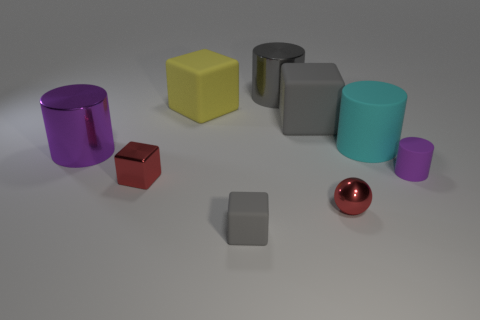Subtract all yellow cubes. How many purple cylinders are left? 2 Add 1 tiny yellow matte things. How many objects exist? 10 Subtract all yellow blocks. How many blocks are left? 3 Subtract all big cyan rubber cylinders. How many cylinders are left? 3 Subtract 1 blocks. How many blocks are left? 3 Subtract all brown cubes. Subtract all red spheres. How many cubes are left? 4 Subtract all blocks. How many objects are left? 5 Subtract 1 red cubes. How many objects are left? 8 Subtract all big gray shiny cubes. Subtract all small red metallic things. How many objects are left? 7 Add 1 big rubber objects. How many big rubber objects are left? 4 